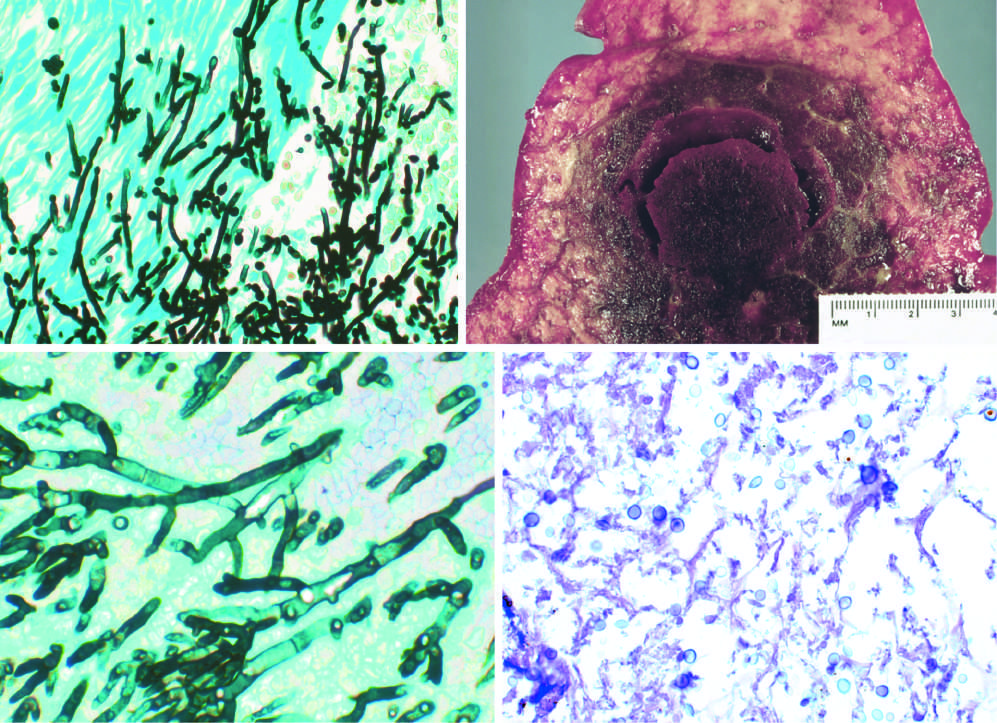does gomori methenamine-silver (gms) stain show septate hyphae with acute-angle branching, consistent with aspergillus?
Answer the question using a single word or phrase. Yes 